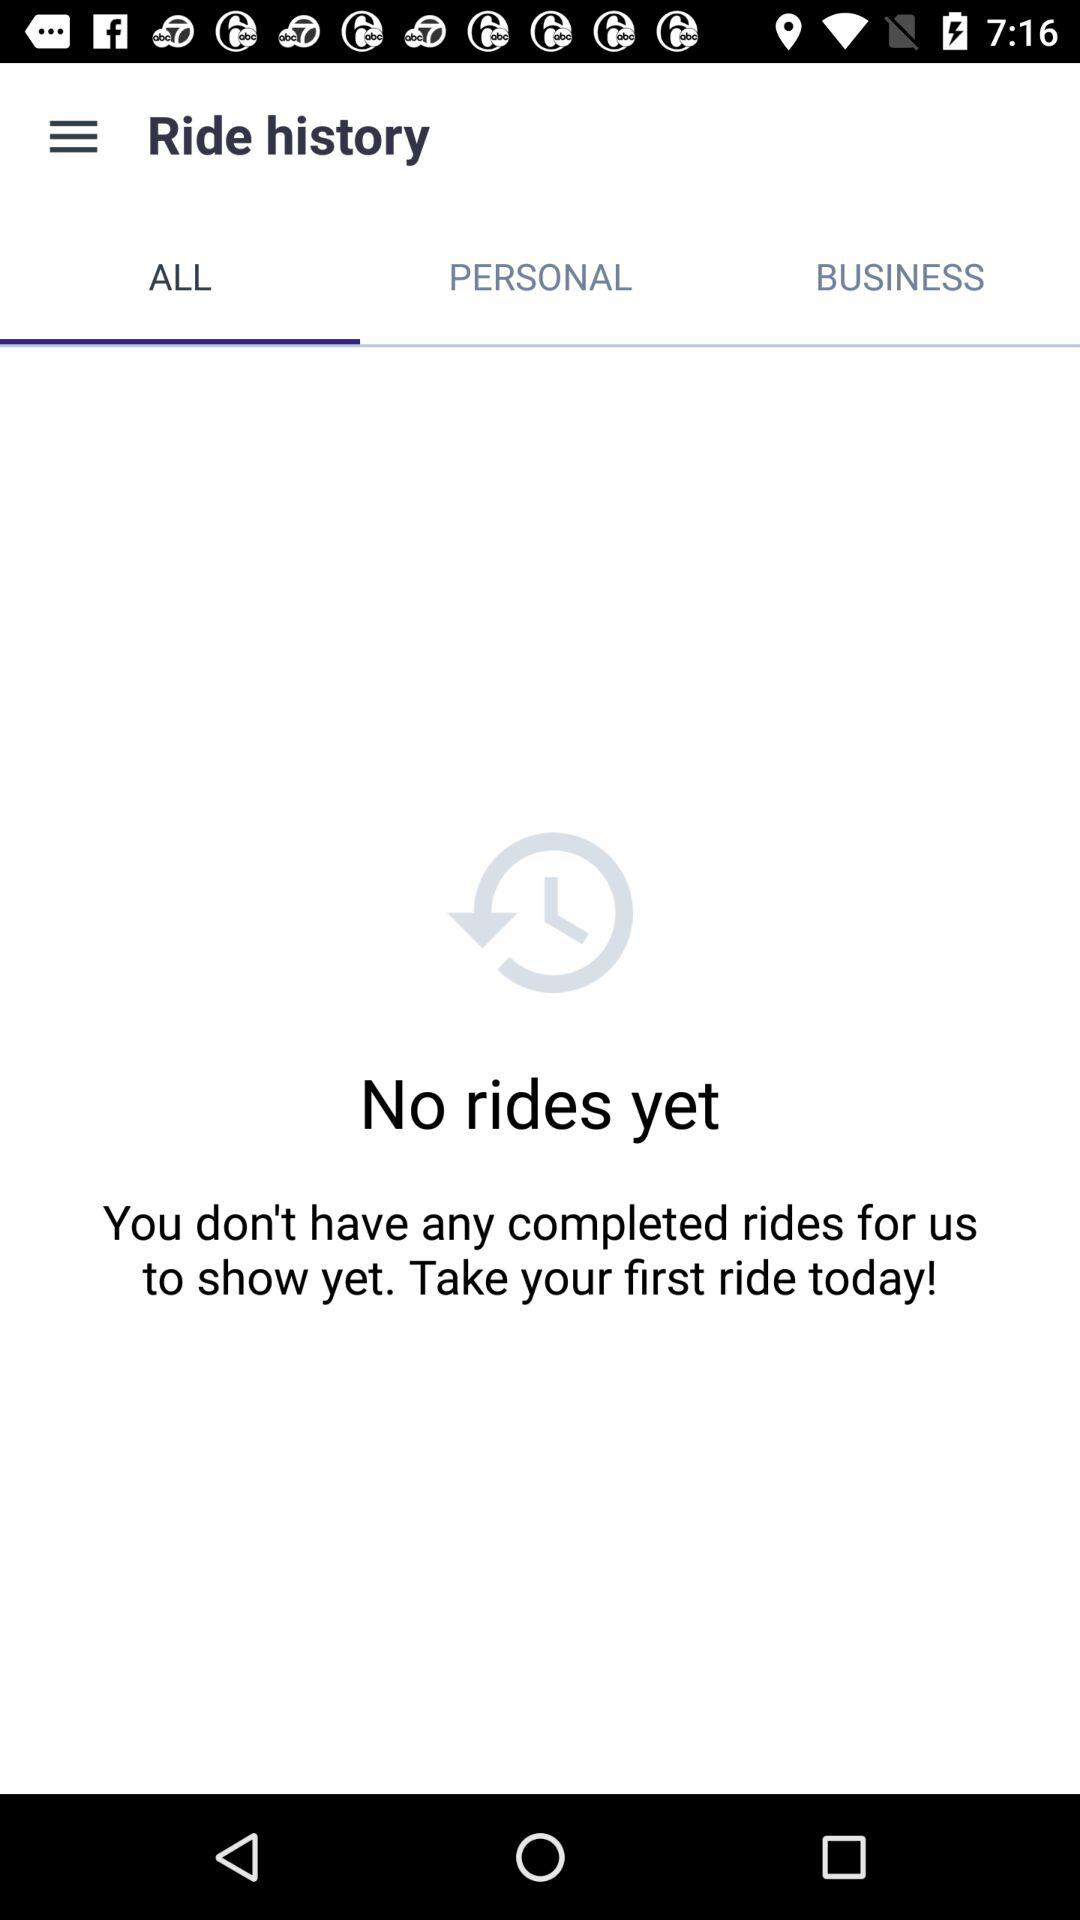How many completed rides do I have?
Answer the question using a single word or phrase. 0 